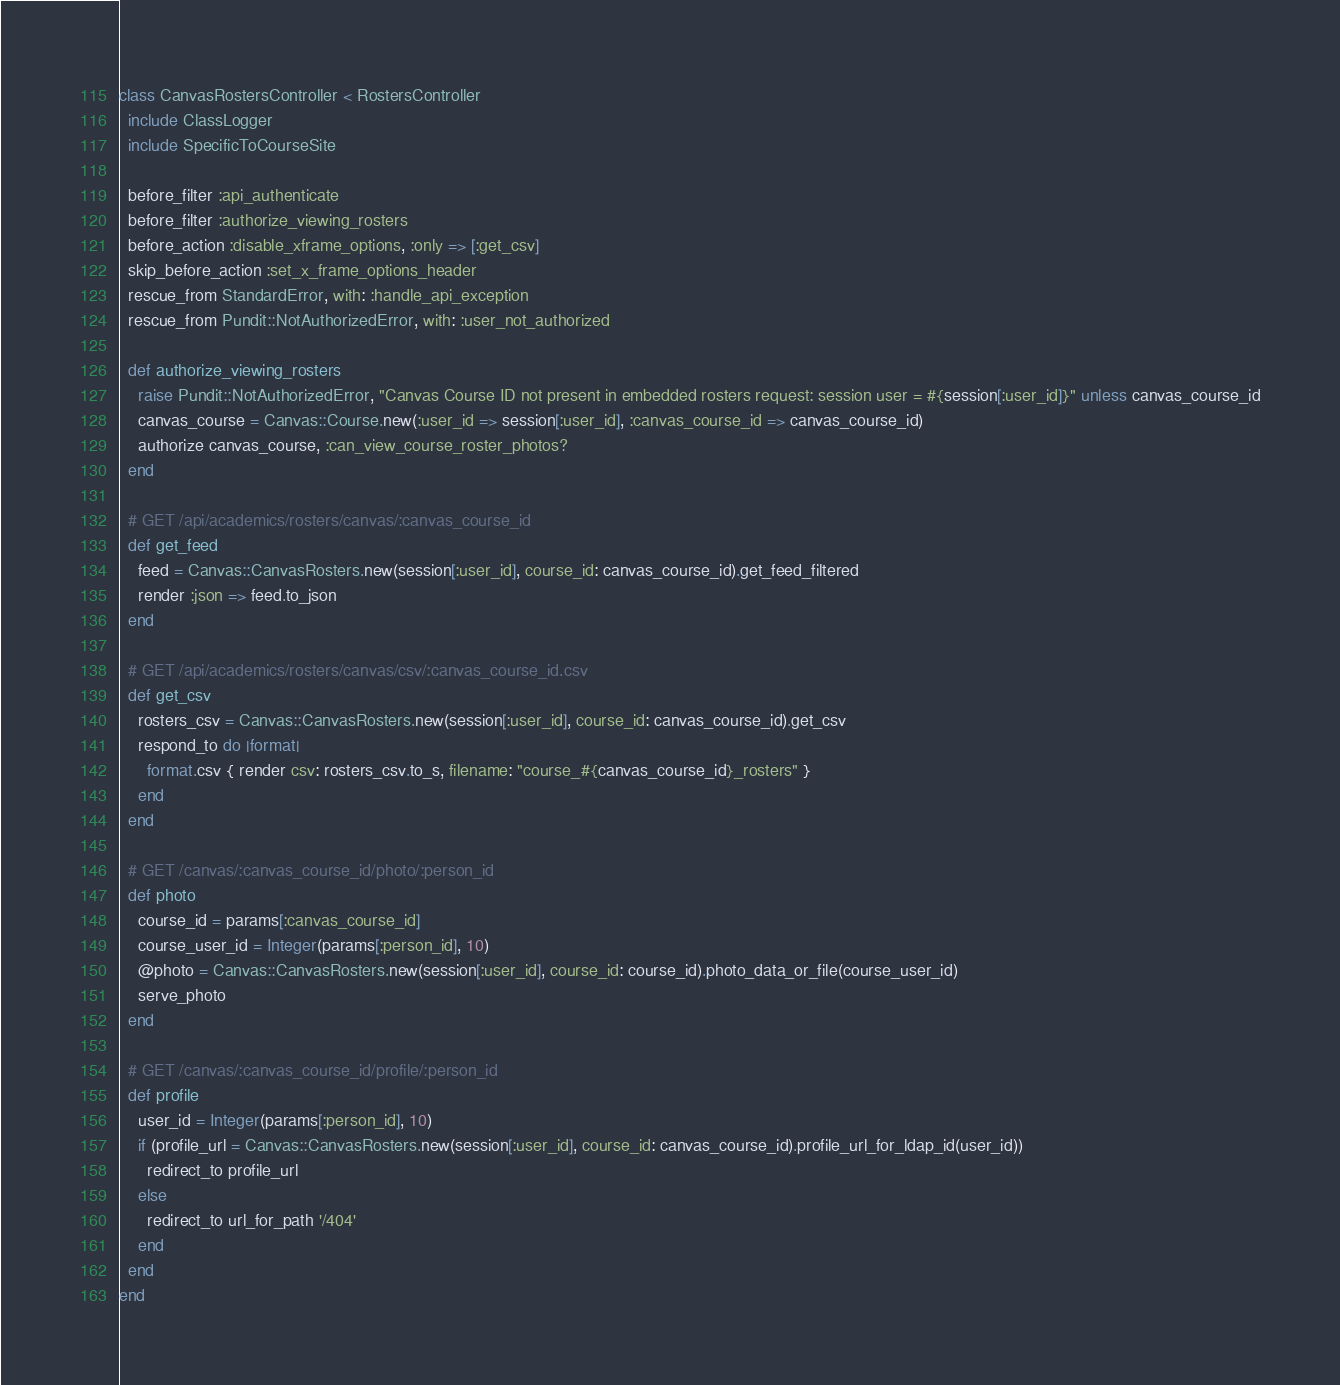<code> <loc_0><loc_0><loc_500><loc_500><_Ruby_>class CanvasRostersController < RostersController
  include ClassLogger
  include SpecificToCourseSite

  before_filter :api_authenticate
  before_filter :authorize_viewing_rosters
  before_action :disable_xframe_options, :only => [:get_csv]
  skip_before_action :set_x_frame_options_header
  rescue_from StandardError, with: :handle_api_exception
  rescue_from Pundit::NotAuthorizedError, with: :user_not_authorized

  def authorize_viewing_rosters
    raise Pundit::NotAuthorizedError, "Canvas Course ID not present in embedded rosters request: session user = #{session[:user_id]}" unless canvas_course_id
    canvas_course = Canvas::Course.new(:user_id => session[:user_id], :canvas_course_id => canvas_course_id)
    authorize canvas_course, :can_view_course_roster_photos?
  end

  # GET /api/academics/rosters/canvas/:canvas_course_id
  def get_feed
    feed = Canvas::CanvasRosters.new(session[:user_id], course_id: canvas_course_id).get_feed_filtered
    render :json => feed.to_json
  end

  # GET /api/academics/rosters/canvas/csv/:canvas_course_id.csv
  def get_csv
    rosters_csv = Canvas::CanvasRosters.new(session[:user_id], course_id: canvas_course_id).get_csv
    respond_to do |format|
      format.csv { render csv: rosters_csv.to_s, filename: "course_#{canvas_course_id}_rosters" }
    end
  end

  # GET /canvas/:canvas_course_id/photo/:person_id
  def photo
    course_id = params[:canvas_course_id]
    course_user_id = Integer(params[:person_id], 10)
    @photo = Canvas::CanvasRosters.new(session[:user_id], course_id: course_id).photo_data_or_file(course_user_id)
    serve_photo
  end

  # GET /canvas/:canvas_course_id/profile/:person_id
  def profile
    user_id = Integer(params[:person_id], 10)
    if (profile_url = Canvas::CanvasRosters.new(session[:user_id], course_id: canvas_course_id).profile_url_for_ldap_id(user_id))
      redirect_to profile_url
    else
      redirect_to url_for_path '/404'
    end
  end
end
</code> 